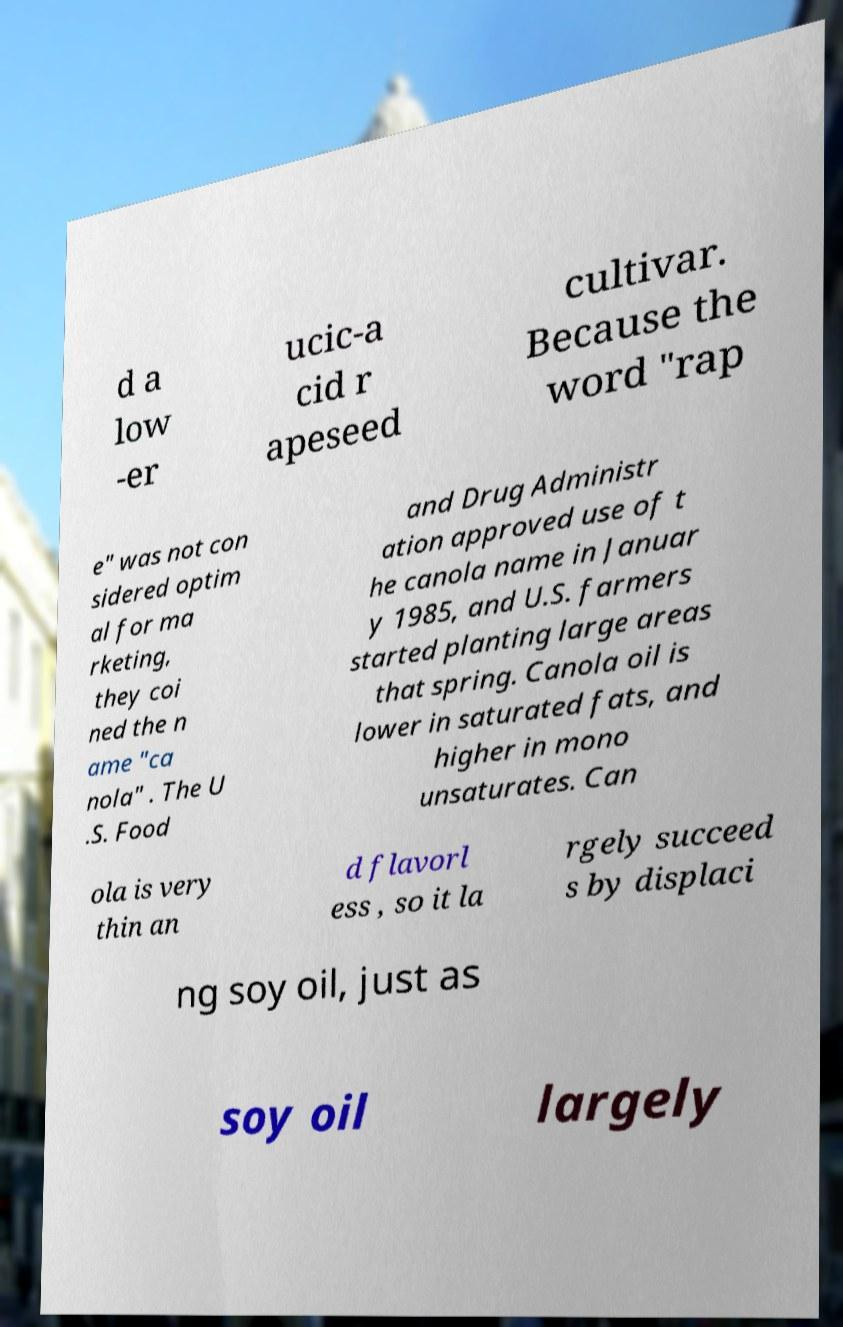Please read and relay the text visible in this image. What does it say? d a low -er ucic-a cid r apeseed cultivar. Because the word "rap e" was not con sidered optim al for ma rketing, they coi ned the n ame "ca nola" . The U .S. Food and Drug Administr ation approved use of t he canola name in Januar y 1985, and U.S. farmers started planting large areas that spring. Canola oil is lower in saturated fats, and higher in mono unsaturates. Can ola is very thin an d flavorl ess , so it la rgely succeed s by displaci ng soy oil, just as soy oil largely 